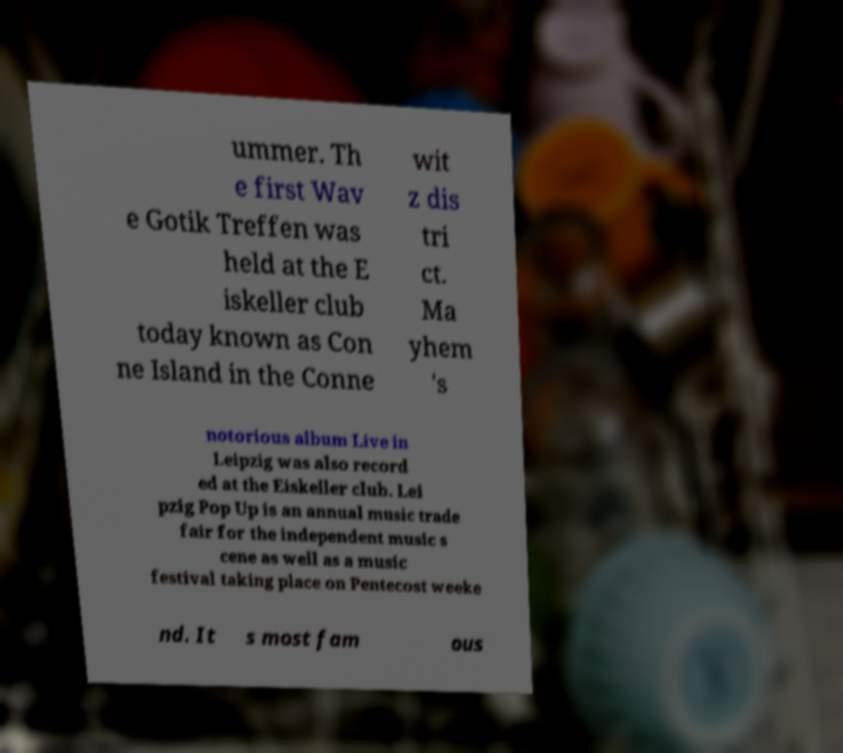Can you accurately transcribe the text from the provided image for me? ummer. Th e first Wav e Gotik Treffen was held at the E iskeller club today known as Con ne Island in the Conne wit z dis tri ct. Ma yhem 's notorious album Live in Leipzig was also record ed at the Eiskeller club. Lei pzig Pop Up is an annual music trade fair for the independent music s cene as well as a music festival taking place on Pentecost weeke nd. It s most fam ous 